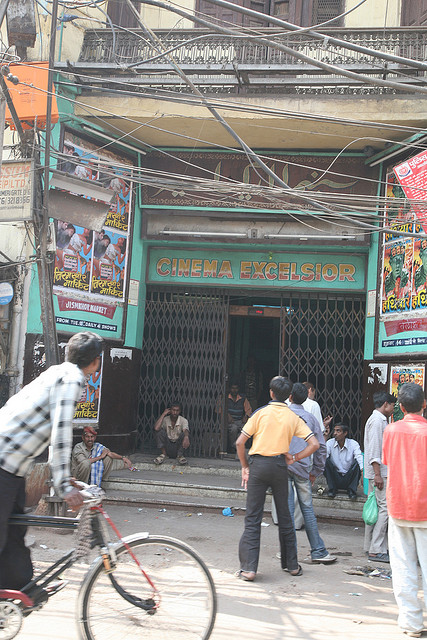Are there any vehicles visible in the picture? Yes, there is one noticeable vehicle in the picture—a bicycle. It is situated on the left side of the image, with a person riding it past the cinema entrance. The presence of the bicycle adds to the everyday and lively character of the scene. 